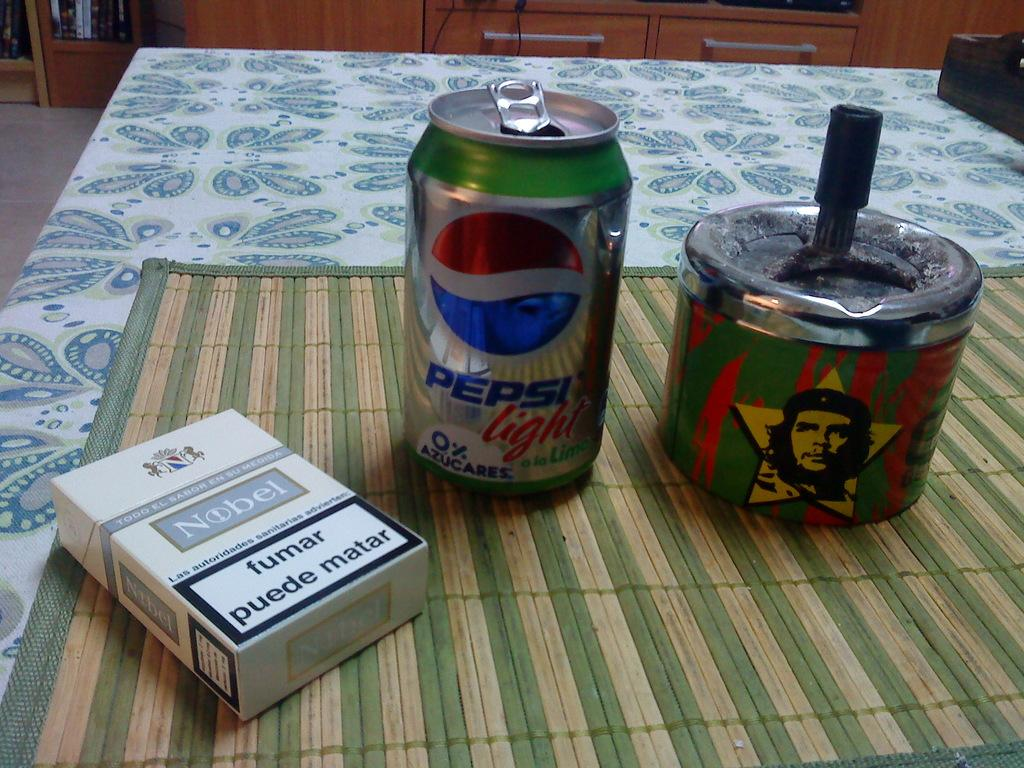What is the main piece of furniture in the image? There is a table in the image. What is on top of the table? There is a mat, tens, and a carton on the table. Can you describe the background of the image? There is a cupboard in the background of the image. What is inside the cupboard? There are things placed in the cupboard. What is the rate of air circulation in the image? There is no information about air circulation in the image, so it cannot be determined. 